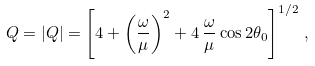Convert formula to latex. <formula><loc_0><loc_0><loc_500><loc_500>Q = | { Q } | = \left [ 4 + \left ( \frac { \omega } { \mu } \right ) ^ { 2 } + 4 \, \frac { \omega } { \mu } \cos 2 \theta _ { 0 } \right ] ^ { 1 / 2 } \, ,</formula> 